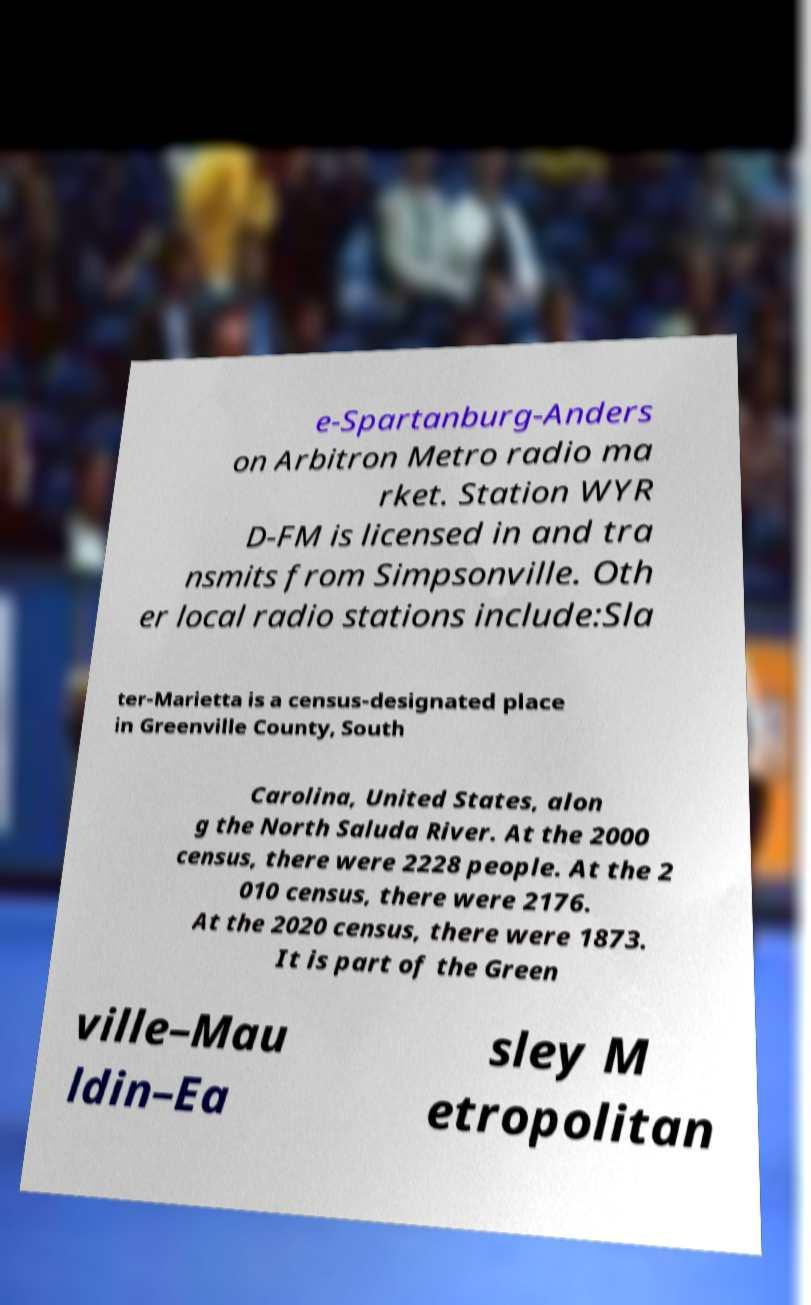Can you read and provide the text displayed in the image?This photo seems to have some interesting text. Can you extract and type it out for me? e-Spartanburg-Anders on Arbitron Metro radio ma rket. Station WYR D-FM is licensed in and tra nsmits from Simpsonville. Oth er local radio stations include:Sla ter-Marietta is a census-designated place in Greenville County, South Carolina, United States, alon g the North Saluda River. At the 2000 census, there were 2228 people. At the 2 010 census, there were 2176. At the 2020 census, there were 1873. It is part of the Green ville–Mau ldin–Ea sley M etropolitan 